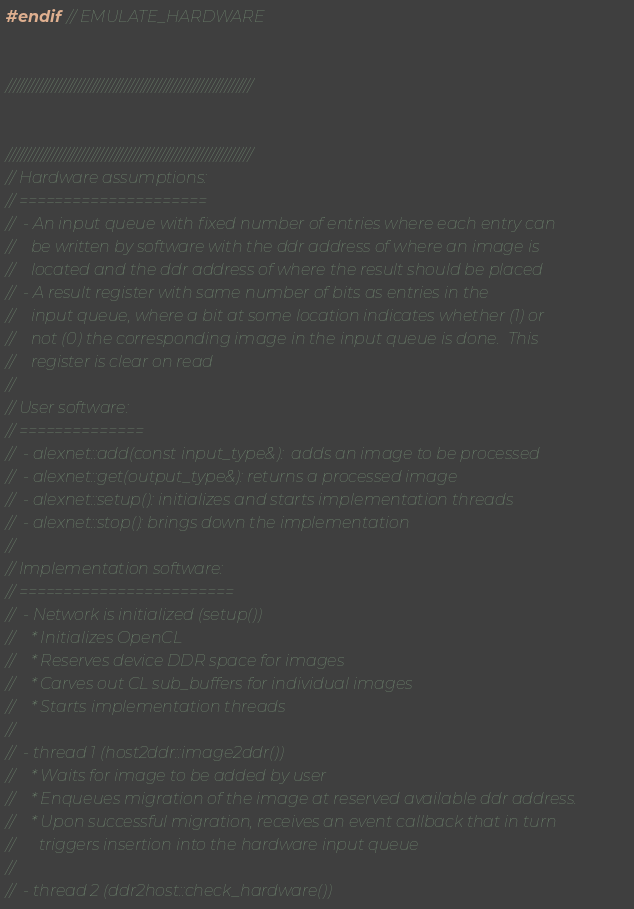Convert code to text. <code><loc_0><loc_0><loc_500><loc_500><_C++_>#endif // EMULATE_HARDWARE


////////////////////////////////////////////////////////////////


////////////////////////////////////////////////////////////////
// Hardware assumptions:
// =====================
//  - An input queue with fixed number of entries where each entry can
//    be written by software with the ddr address of where an image is
//    located and the ddr address of where the result should be placed
//  - A result register with same number of bits as entries in the
//    input queue, where a bit at some location indicates whether (1) or
//    not (0) the corresponding image in the input queue is done.  This
//    register is clear on read
//
// User software:
// ==============
//  - alexnet::add(const input_type&):  adds an image to be processed
//  - alexnet::get(output_type&): returns a processed image
//  - alexnet::setup(): initializes and starts implementation threads
//  - alexnet::stop(): brings down the implementation
//
// Implementation software:
// ========================
//  - Network is initialized (setup())
//    * Initializes OpenCL
//    * Reserves device DDR space for images
//    * Carves out CL sub_buffers for individual images
//    * Starts implementation threads
//
//  - thread 1 (host2ddr::image2ddr())
//    * Waits for image to be added by user
//    * Enqueues migration of the image at reserved available ddr address.
//    * Upon successful migration, receives an event callback that in turn
//      triggers insertion into the hardware input queue
//
//  - thread 2 (ddr2host::check_hardware())</code> 